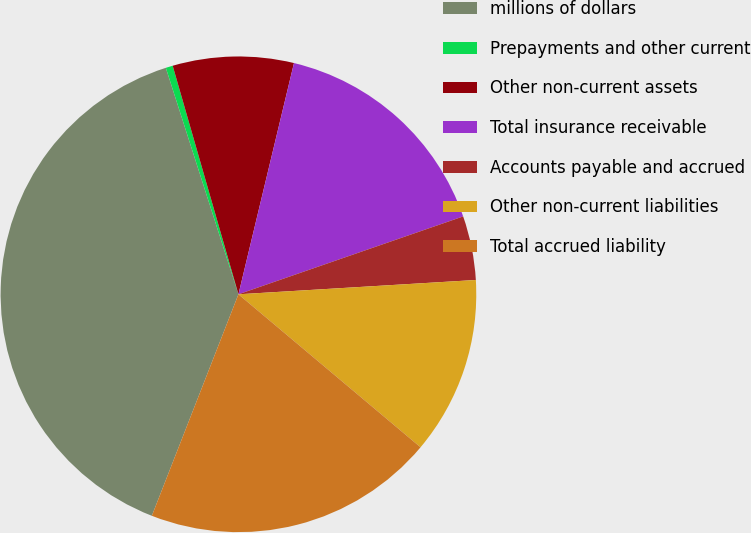Convert chart to OTSL. <chart><loc_0><loc_0><loc_500><loc_500><pie_chart><fcel>millions of dollars<fcel>Prepayments and other current<fcel>Other non-current assets<fcel>Total insurance receivable<fcel>Accounts payable and accrued<fcel>Other non-current liabilities<fcel>Total accrued liability<nl><fcel>39.13%<fcel>0.48%<fcel>8.21%<fcel>15.94%<fcel>4.35%<fcel>12.08%<fcel>19.81%<nl></chart> 